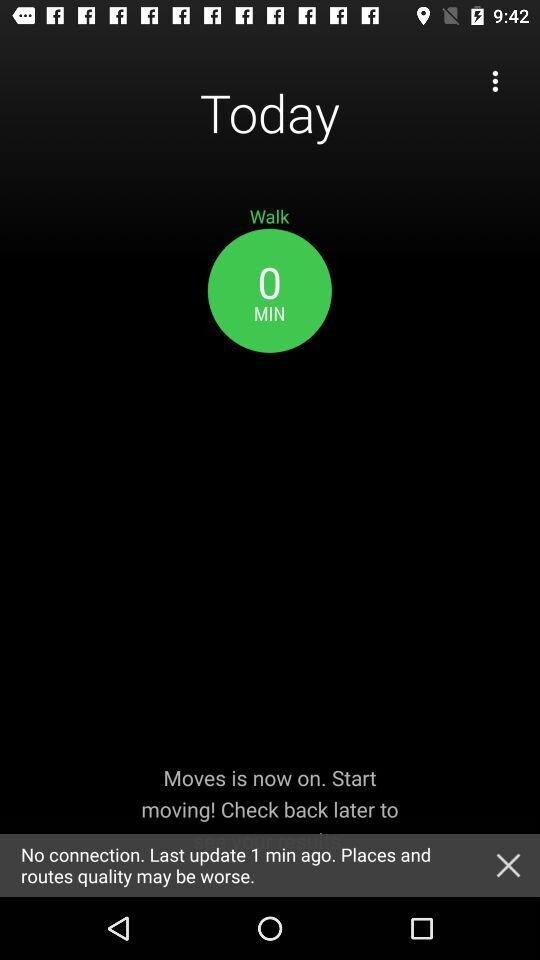When was the last update? The last update was 1 minute ago. 